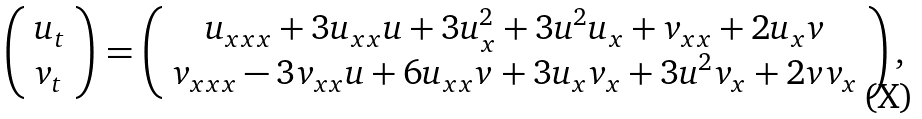Convert formula to latex. <formula><loc_0><loc_0><loc_500><loc_500>\left ( \begin{array} { l } u _ { t } \\ v _ { t } \end{array} \right ) = \left ( \begin{array} { c c } u _ { x x x } + 3 u _ { x x } u + 3 u _ { x } ^ { 2 } + 3 u ^ { 2 } u _ { x } + v _ { x x } + 2 u _ { x } v \\ v _ { x x x } - 3 v _ { x x } u + 6 u _ { x x } v + 3 u _ { x } v _ { x } + 3 u ^ { 2 } v _ { x } + 2 v v _ { x } \end{array} \right ) ,</formula> 